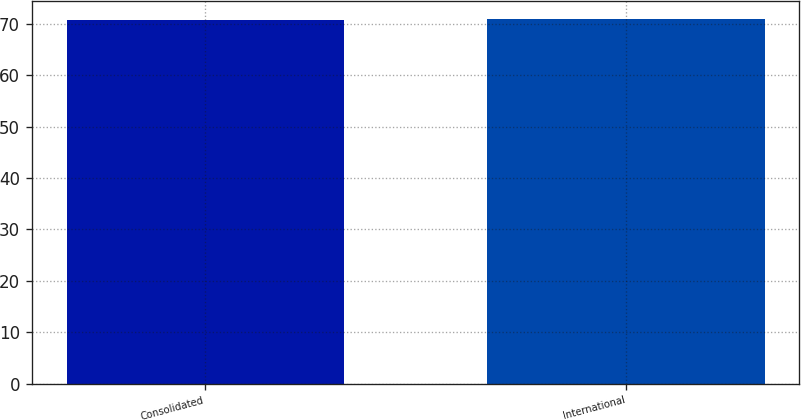<chart> <loc_0><loc_0><loc_500><loc_500><bar_chart><fcel>Consolidated<fcel>International<nl><fcel>70.8<fcel>70.9<nl></chart> 